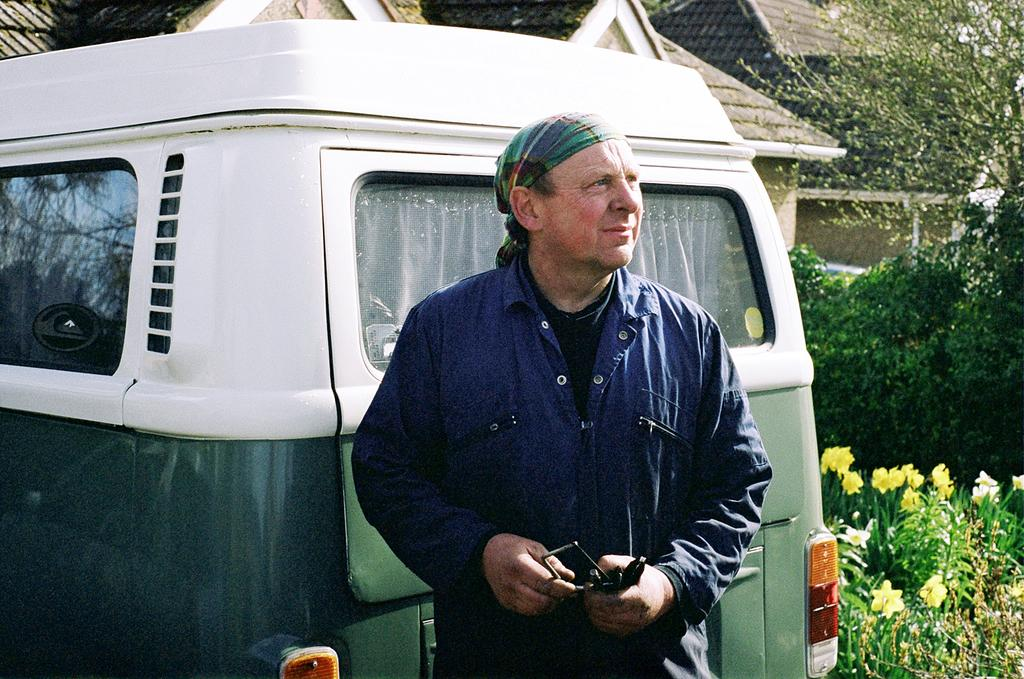What is the main subject in the middle of the image? There is a man standing in the middle of the image. What is located behind the man? There is a vehicle behind the man. What can be seen in the distance in the image? There are buildings and trees in the background of the image. Where are the flower plants located in the image? Flower plants are present at the bottom right of the image. What type of jam is being spread on the dog in the image? There is no dog or jam present in the image. 